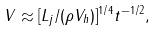Convert formula to latex. <formula><loc_0><loc_0><loc_500><loc_500>V \approx [ L _ { j } / ( \rho V _ { h } ) ] ^ { 1 / 4 } t ^ { - 1 / 2 } ,</formula> 